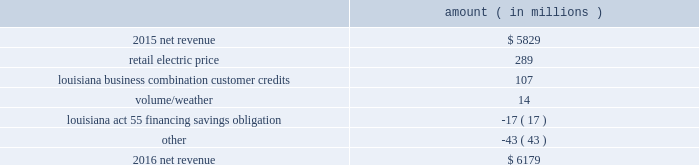( $ 66 million net-of-tax ) as a result of customer credits to be realized by electric customers of entergy louisiana , consistent with the terms of the stipulated settlement in the business combination proceeding .
See note 2 to the financial statements for further discussion of the business combination and customer credits .
Results of operations for 2015 also include the sale in december 2015 of the 583 mw rhode island state energy center for a realized gain of $ 154 million ( $ 100 million net-of-tax ) on the sale and the $ 77 million ( $ 47 million net-of-tax ) write-off and regulatory charges to recognize that a portion of the assets associated with the waterford 3 replacement steam generator project is no longer probable of recovery .
See note 14 to the financial statements for further discussion of the rhode island state energy center sale .
See note 2 to the financial statements for further discussion of the waterford 3 replacement steam generator prudence review proceeding .
Net revenue utility following is an analysis of the change in net revenue comparing 2016 to 2015 .
Amount ( in millions ) .
The retail electric price variance is primarily due to : 2022 an increase in base rates at entergy arkansas , as approved by the apsc .
The new rates were effective february 24 , 2016 and began billing with the first billing cycle of april 2016 .
The increase included an interim base rate adjustment surcharge , effective with the first billing cycle of april 2016 , to recover the incremental revenue requirement for the period february 24 , 2016 through march 31 , 2016 .
A significant portion of the increase was related to the purchase of power block 2 of the union power station ; 2022 an increase in the purchased power and capacity acquisition cost recovery rider for entergy new orleans , as approved by the city council , effective with the first billing cycle of march 2016 , primarily related to the purchase of power block 1 of the union power station ; 2022 an increase in formula rate plan revenues for entergy louisiana , implemented with the first billing cycle of march 2016 , to collect the estimated first-year revenue requirement related to the purchase of power blocks 3 and 4 of the union power station ; and 2022 an increase in revenues at entergy mississippi , as approved by the mpsc , effective with the first billing cycle of july 2016 , and an increase in revenues collected through the storm damage rider .
See note 2 to the financial statements for further discussion of the rate proceedings .
See note 14 to the financial statements for discussion of the union power station purchase .
The louisiana business combination customer credits variance is due to a regulatory liability of $ 107 million recorded by entergy in october 2015 as a result of the entergy gulf states louisiana and entergy louisiana business combination .
Consistent with the terms of the stipulated settlement in the business combination proceeding , electric customers of entergy louisiana will realize customer credits associated with the business combination ; accordingly , in october 2015 , entergy recorded a regulatory liability of $ 107 million ( $ 66 million net-of-tax ) .
These costs are being entergy corporation and subsidiaries management 2019s financial discussion and analysis .
What is the percent change in net revenue from 2015 to 2016? 
Computations: ((6179 - 5829) / 5829)
Answer: 0.06004. 